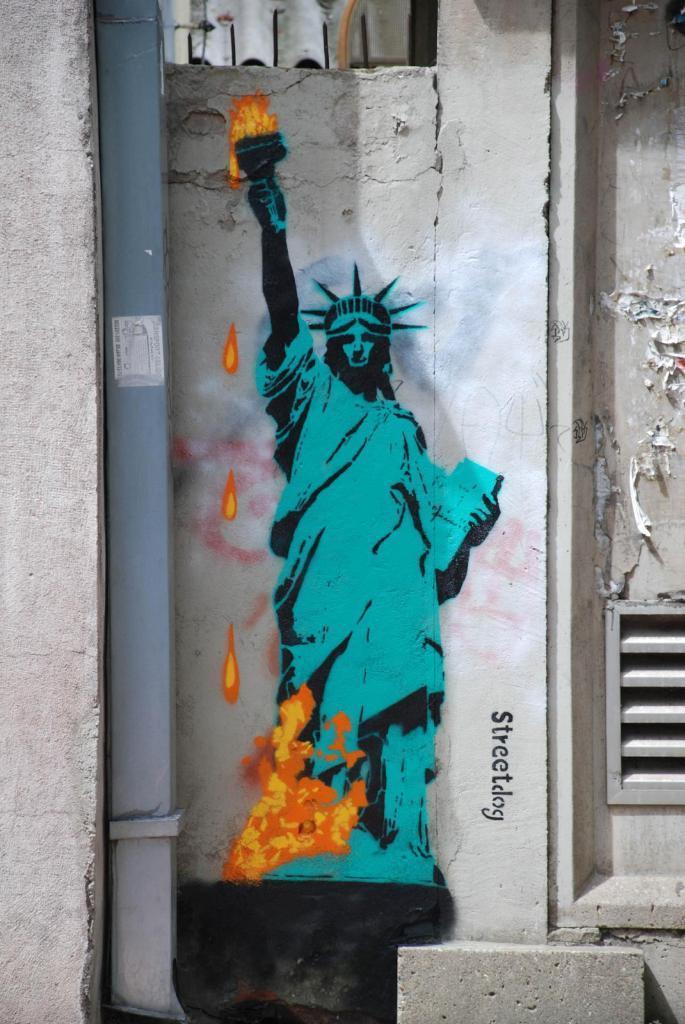In one or two sentences, can you explain what this image depicts? In the center of the image we can see painting on the wall. 